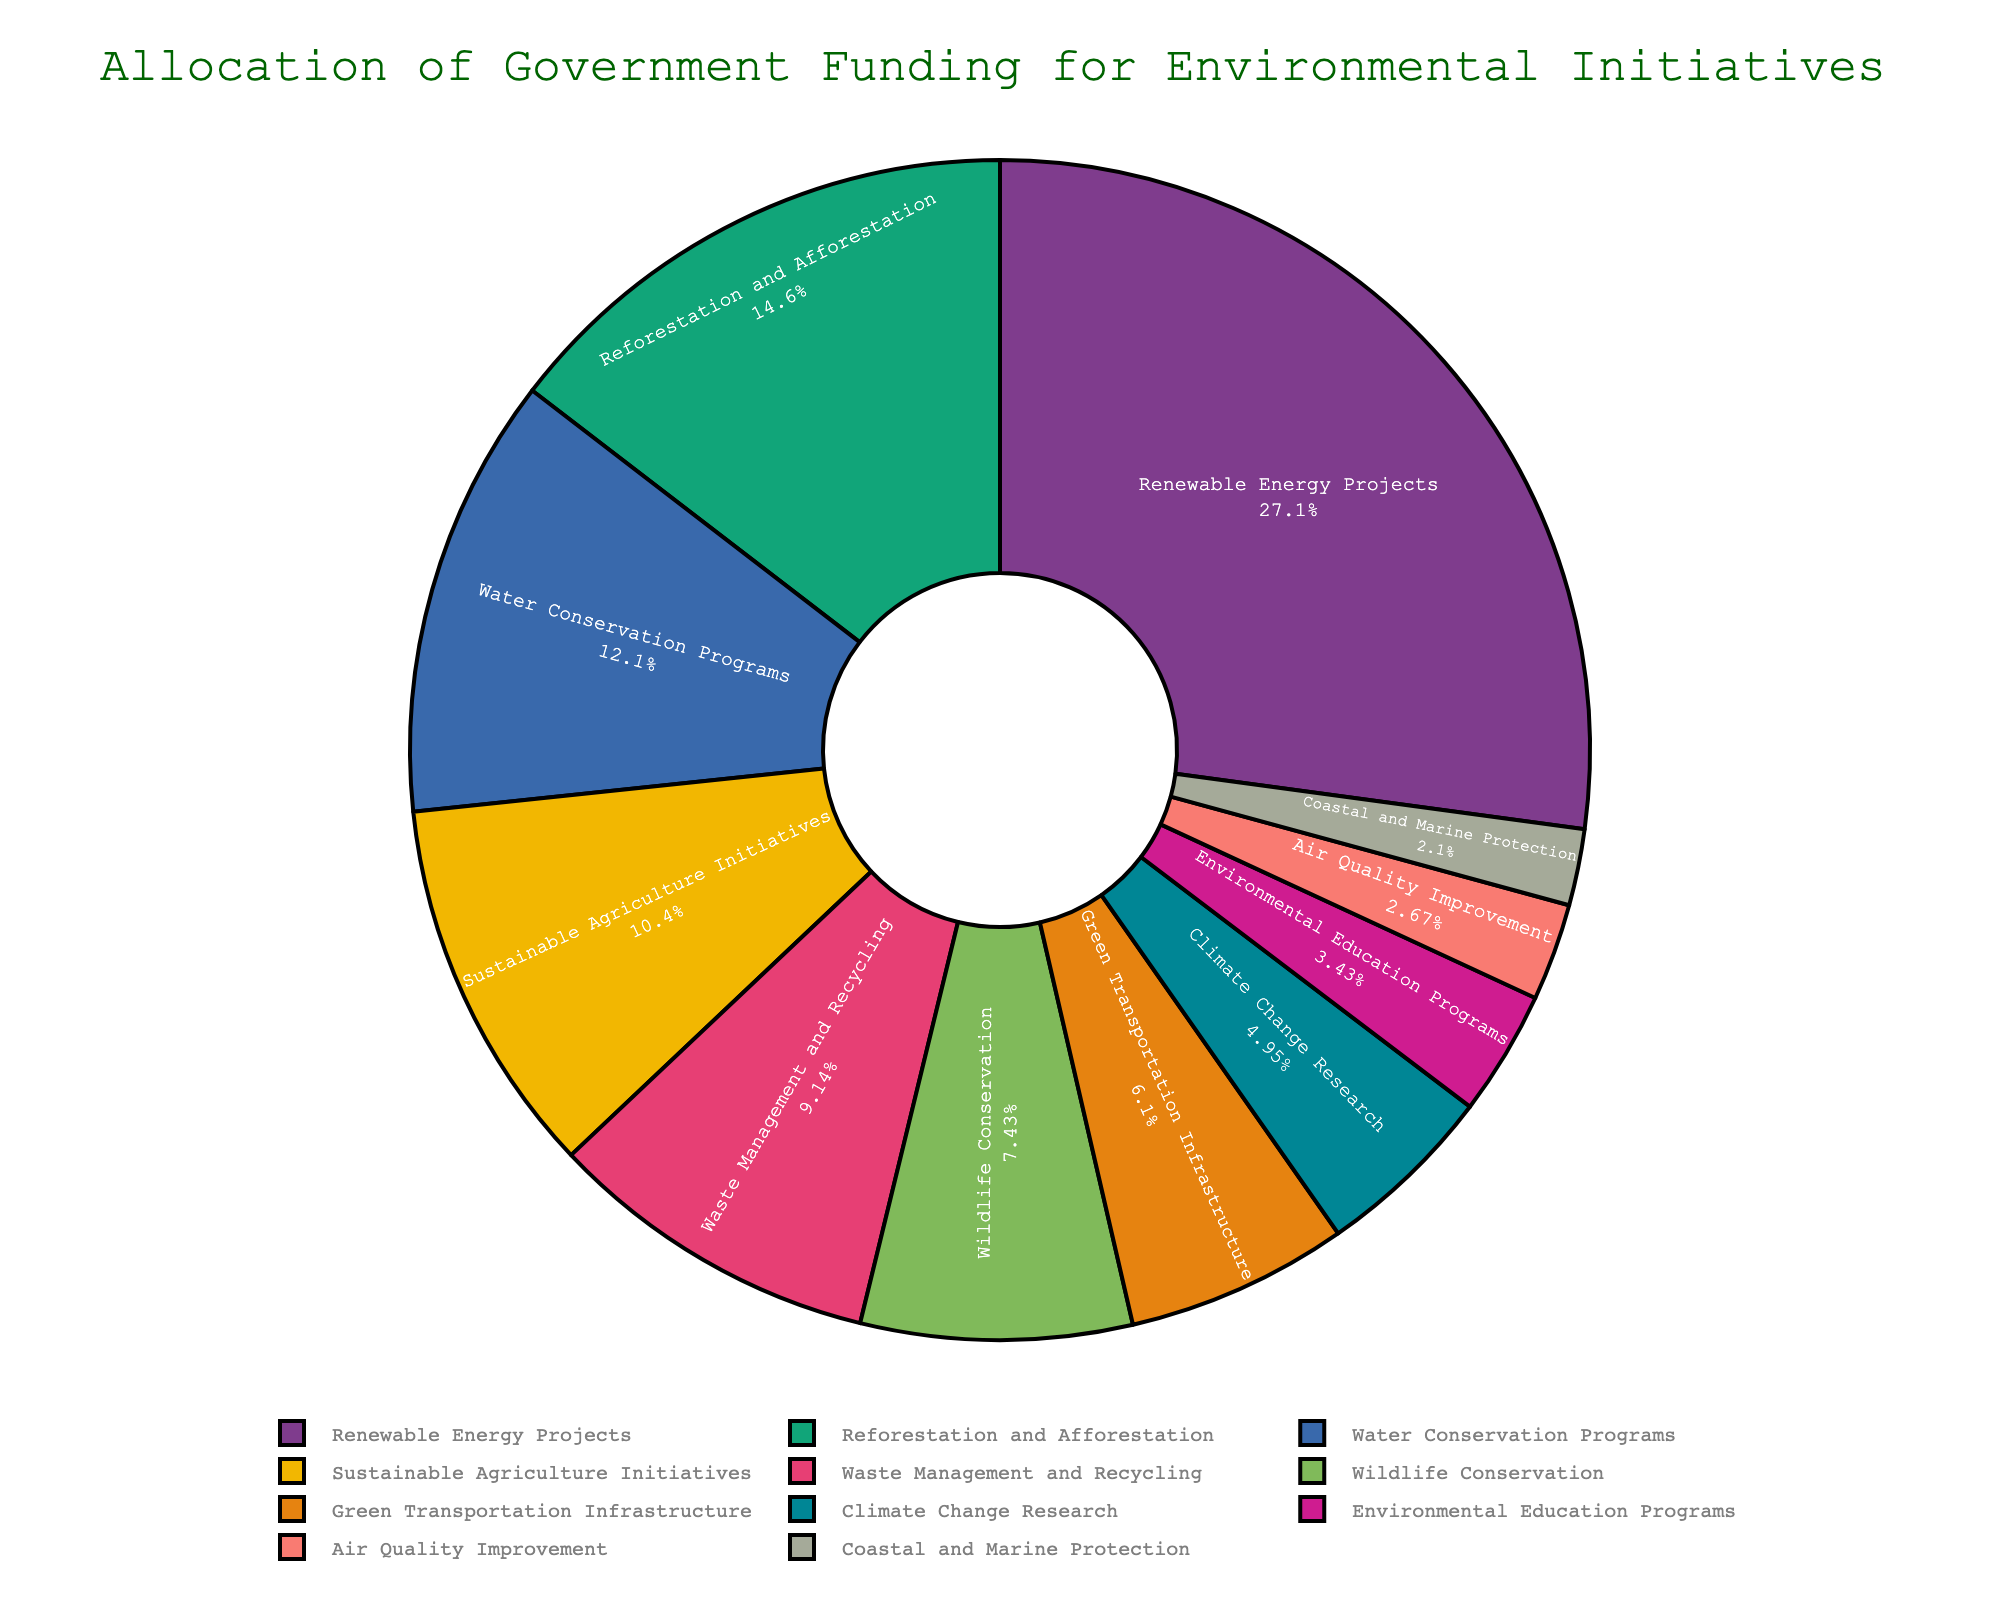What percentage of total funding goes to Renewable Energy Projects? By looking at the pie chart, locate the segment labeled "Renewable Energy Projects" and check the percentage displayed for it.
Answer: 28.5% What is the total funding percentage for Wildlife Conservation and Air Quality Improvement combined? First, find the percentages for "Wildlife Conservation" and "Air Quality Improvement" from the pie chart. Then, add the two percentages together: 7.8% + 2.8% = 10.6%.
Answer: 10.6% Which environmental initiative receives more funding: Water Conservation Programs or Sustainable Agriculture Initiatives? Compare the segments labeled "Water Conservation Programs" and "Sustainable Agriculture Initiatives" on the pie chart. Water Conservation Programs have a larger percentage (12.7%) compared to Sustainable Agriculture Initiatives (10.9%).
Answer: Water Conservation Programs Is the funding percentage for Waste Management and Recycling greater than that for Climate Change Research? Check the segments labeled "Waste Management and Recycling" and "Climate Change Research" on the pie chart. Waste Management and Recycling is 9.6%, while Climate Change Research is 5.2%; thus, Waste Management and Recycling has a greater percentage.
Answer: Yes What is the difference in funding percentage between Green Transportation Infrastructure and Reforestation and Afforestation? Find the funding percentages for "Green Transportation Infrastructure" (6.4%) and "Reforestation and Afforestation" (15.3%). Then, subtract the smaller percentage from the larger one: 15.3% - 6.4% = 8.9%.
Answer: 8.9% Which category gets the least amount of funding and what is its percentage? Locate the smallest segment on the pie chart and check its corresponding label and percentage. The smallest segment is "Coastal and Marine Protection" with 2.2%.
Answer: Coastal and Marine Protection, 2.2% By how much does the funding for Renewable Energy Projects exceed that for Climate Change Research? Compare the funding percentages for "Renewable Energy Projects" (28.5%) and "Climate Change Research" (5.2%). Subtract the smaller percentage from the larger one: 28.5% - 5.2% = 23.3%.
Answer: 23.3% What is the sum of the funding percentages for the four initiatives with the smallest allocations? Identify the four categories with the smallest percentages: "Air Quality Improvement" (2.8%), "Coastal and Marine Protection" (2.2%), "Environmental Education Programs" (3.6%), and "Climate Change Research" (5.2%). Add these percentages together: 2.8% + 2.2% + 3.6% + 5.2% = 13.8%.
Answer: 13.8% How does the funding for Reforestation and Afforestation compare to the funding for Water Conservation Programs and Sustainable Agriculture Initiatives combined? First, find and add the funding percentages for "Water Conservation Programs" (12.7%) and "Sustainable Agriculture Initiatives" (10.9%): 12.7% + 10.9% = 23.6%. Then, compare it with "Reforestation and Afforestation" (15.3%). 23.6% is greater than 15.3%.
Answer: Reforestation and Afforestation has less funding than the combined funding for Water Conservation Programs and Sustainable Agriculture Initiatives What is the total funding percentage for categories related to conservation (Wildlife Conservation, Coastal and Marine Protection, and Reforestation and Afforestation)? Find the percentages for the conservation-related categories: "Wildlife Conservation" (7.8%), "Coastal and Marine Protection" (2.2%), and "Reforestation and Afforestation" (15.3%). Add the percentages together: 7.8% + 2.2% + 15.3% = 25.3%.
Answer: 25.3% 